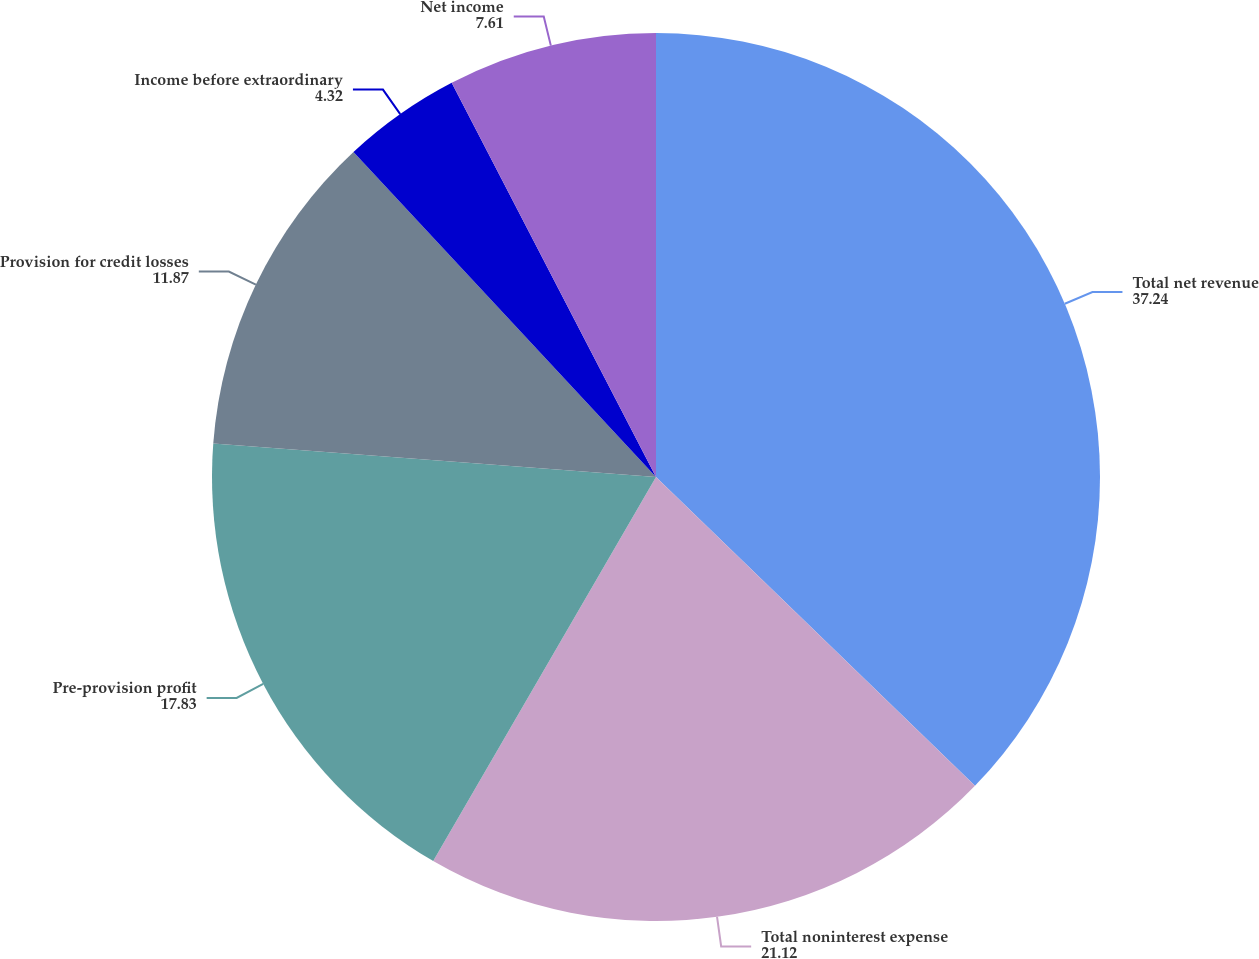Convert chart to OTSL. <chart><loc_0><loc_0><loc_500><loc_500><pie_chart><fcel>Total net revenue<fcel>Total noninterest expense<fcel>Pre-provision profit<fcel>Provision for credit losses<fcel>Income before extraordinary<fcel>Net income<nl><fcel>37.24%<fcel>21.12%<fcel>17.83%<fcel>11.87%<fcel>4.32%<fcel>7.61%<nl></chart> 